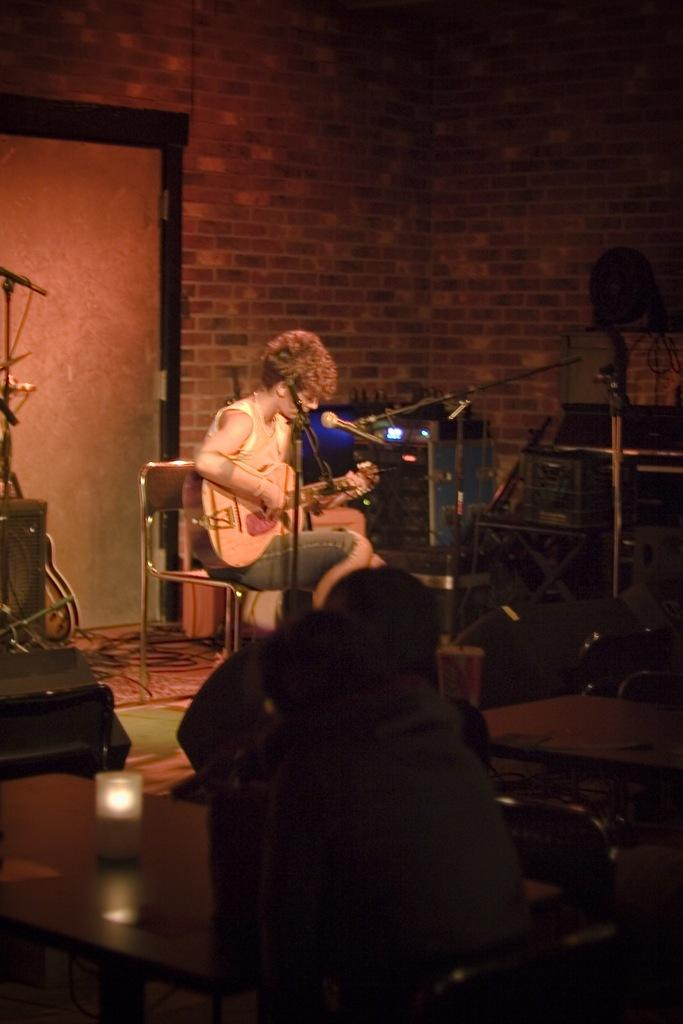What is the person in the image doing? The person is sitting in a chair and playing a guitar. What is the person in front of? The person is in front of a microphone. How many other people are sitting in chairs in the image? There are two other persons sitting in chairs in the image. What can be seen in the right corner of the image? There is a table in the right corner of the image. What type of jar is visible on the person's head in the image? There is no jar visible on the person's head in the image. What is the person's brain doing while playing the guitar? The person's brain is not visible in the image, so it is impossible to determine what it is doing. 